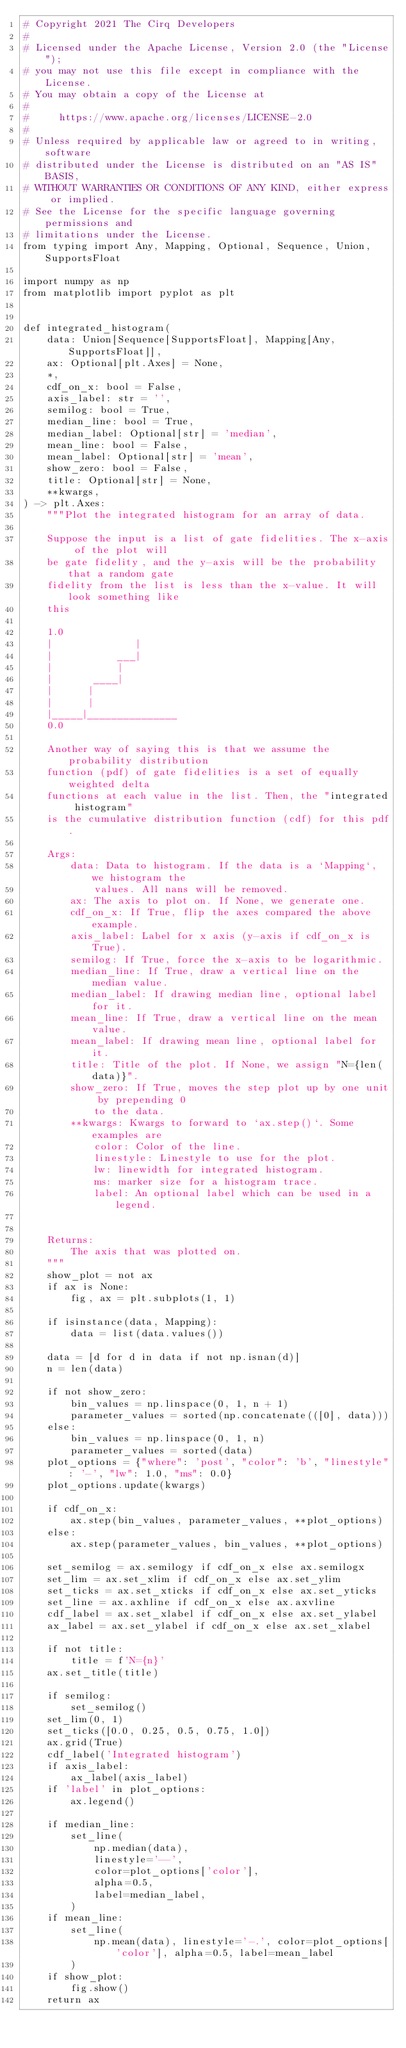<code> <loc_0><loc_0><loc_500><loc_500><_Python_># Copyright 2021 The Cirq Developers
#
# Licensed under the Apache License, Version 2.0 (the "License");
# you may not use this file except in compliance with the License.
# You may obtain a copy of the License at
#
#     https://www.apache.org/licenses/LICENSE-2.0
#
# Unless required by applicable law or agreed to in writing, software
# distributed under the License is distributed on an "AS IS" BASIS,
# WITHOUT WARRANTIES OR CONDITIONS OF ANY KIND, either express or implied.
# See the License for the specific language governing permissions and
# limitations under the License.
from typing import Any, Mapping, Optional, Sequence, Union, SupportsFloat

import numpy as np
from matplotlib import pyplot as plt


def integrated_histogram(
    data: Union[Sequence[SupportsFloat], Mapping[Any, SupportsFloat]],
    ax: Optional[plt.Axes] = None,
    *,
    cdf_on_x: bool = False,
    axis_label: str = '',
    semilog: bool = True,
    median_line: bool = True,
    median_label: Optional[str] = 'median',
    mean_line: bool = False,
    mean_label: Optional[str] = 'mean',
    show_zero: bool = False,
    title: Optional[str] = None,
    **kwargs,
) -> plt.Axes:
    """Plot the integrated histogram for an array of data.

    Suppose the input is a list of gate fidelities. The x-axis of the plot will
    be gate fidelity, and the y-axis will be the probability that a random gate
    fidelity from the list is less than the x-value. It will look something like
    this

    1.0
    |              |
    |           ___|
    |           |
    |       ____|
    |      |
    |      |
    |_____|_______________
    0.0

    Another way of saying this is that we assume the probability distribution
    function (pdf) of gate fidelities is a set of equally weighted delta
    functions at each value in the list. Then, the "integrated histogram"
    is the cumulative distribution function (cdf) for this pdf.

    Args:
        data: Data to histogram. If the data is a `Mapping`, we histogram the
            values. All nans will be removed.
        ax: The axis to plot on. If None, we generate one.
        cdf_on_x: If True, flip the axes compared the above example.
        axis_label: Label for x axis (y-axis if cdf_on_x is True).
        semilog: If True, force the x-axis to be logarithmic.
        median_line: If True, draw a vertical line on the median value.
        median_label: If drawing median line, optional label for it.
        mean_line: If True, draw a vertical line on the mean value.
        mean_label: If drawing mean line, optional label for it.
        title: Title of the plot. If None, we assign "N={len(data)}".
        show_zero: If True, moves the step plot up by one unit by prepending 0
            to the data.
        **kwargs: Kwargs to forward to `ax.step()`. Some examples are
            color: Color of the line.
            linestyle: Linestyle to use for the plot.
            lw: linewidth for integrated histogram.
            ms: marker size for a histogram trace.
            label: An optional label which can be used in a legend.


    Returns:
        The axis that was plotted on.
    """
    show_plot = not ax
    if ax is None:
        fig, ax = plt.subplots(1, 1)

    if isinstance(data, Mapping):
        data = list(data.values())

    data = [d for d in data if not np.isnan(d)]
    n = len(data)

    if not show_zero:
        bin_values = np.linspace(0, 1, n + 1)
        parameter_values = sorted(np.concatenate(([0], data)))
    else:
        bin_values = np.linspace(0, 1, n)
        parameter_values = sorted(data)
    plot_options = {"where": 'post', "color": 'b', "linestyle": '-', "lw": 1.0, "ms": 0.0}
    plot_options.update(kwargs)

    if cdf_on_x:
        ax.step(bin_values, parameter_values, **plot_options)
    else:
        ax.step(parameter_values, bin_values, **plot_options)

    set_semilog = ax.semilogy if cdf_on_x else ax.semilogx
    set_lim = ax.set_xlim if cdf_on_x else ax.set_ylim
    set_ticks = ax.set_xticks if cdf_on_x else ax.set_yticks
    set_line = ax.axhline if cdf_on_x else ax.axvline
    cdf_label = ax.set_xlabel if cdf_on_x else ax.set_ylabel
    ax_label = ax.set_ylabel if cdf_on_x else ax.set_xlabel

    if not title:
        title = f'N={n}'
    ax.set_title(title)

    if semilog:
        set_semilog()
    set_lim(0, 1)
    set_ticks([0.0, 0.25, 0.5, 0.75, 1.0])
    ax.grid(True)
    cdf_label('Integrated histogram')
    if axis_label:
        ax_label(axis_label)
    if 'label' in plot_options:
        ax.legend()

    if median_line:
        set_line(
            np.median(data),
            linestyle='--',
            color=plot_options['color'],
            alpha=0.5,
            label=median_label,
        )
    if mean_line:
        set_line(
            np.mean(data), linestyle='-.', color=plot_options['color'], alpha=0.5, label=mean_label
        )
    if show_plot:
        fig.show()
    return ax
</code> 